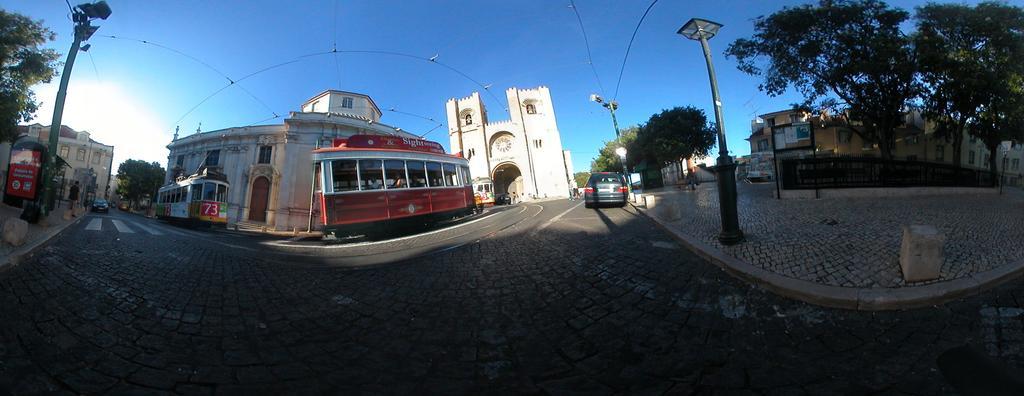Please provide a concise description of this image. In this image we can see some cars and buses on the road. We can also see some buildings with windows, a pole, street lights, trees, a board, fence and the sky. 